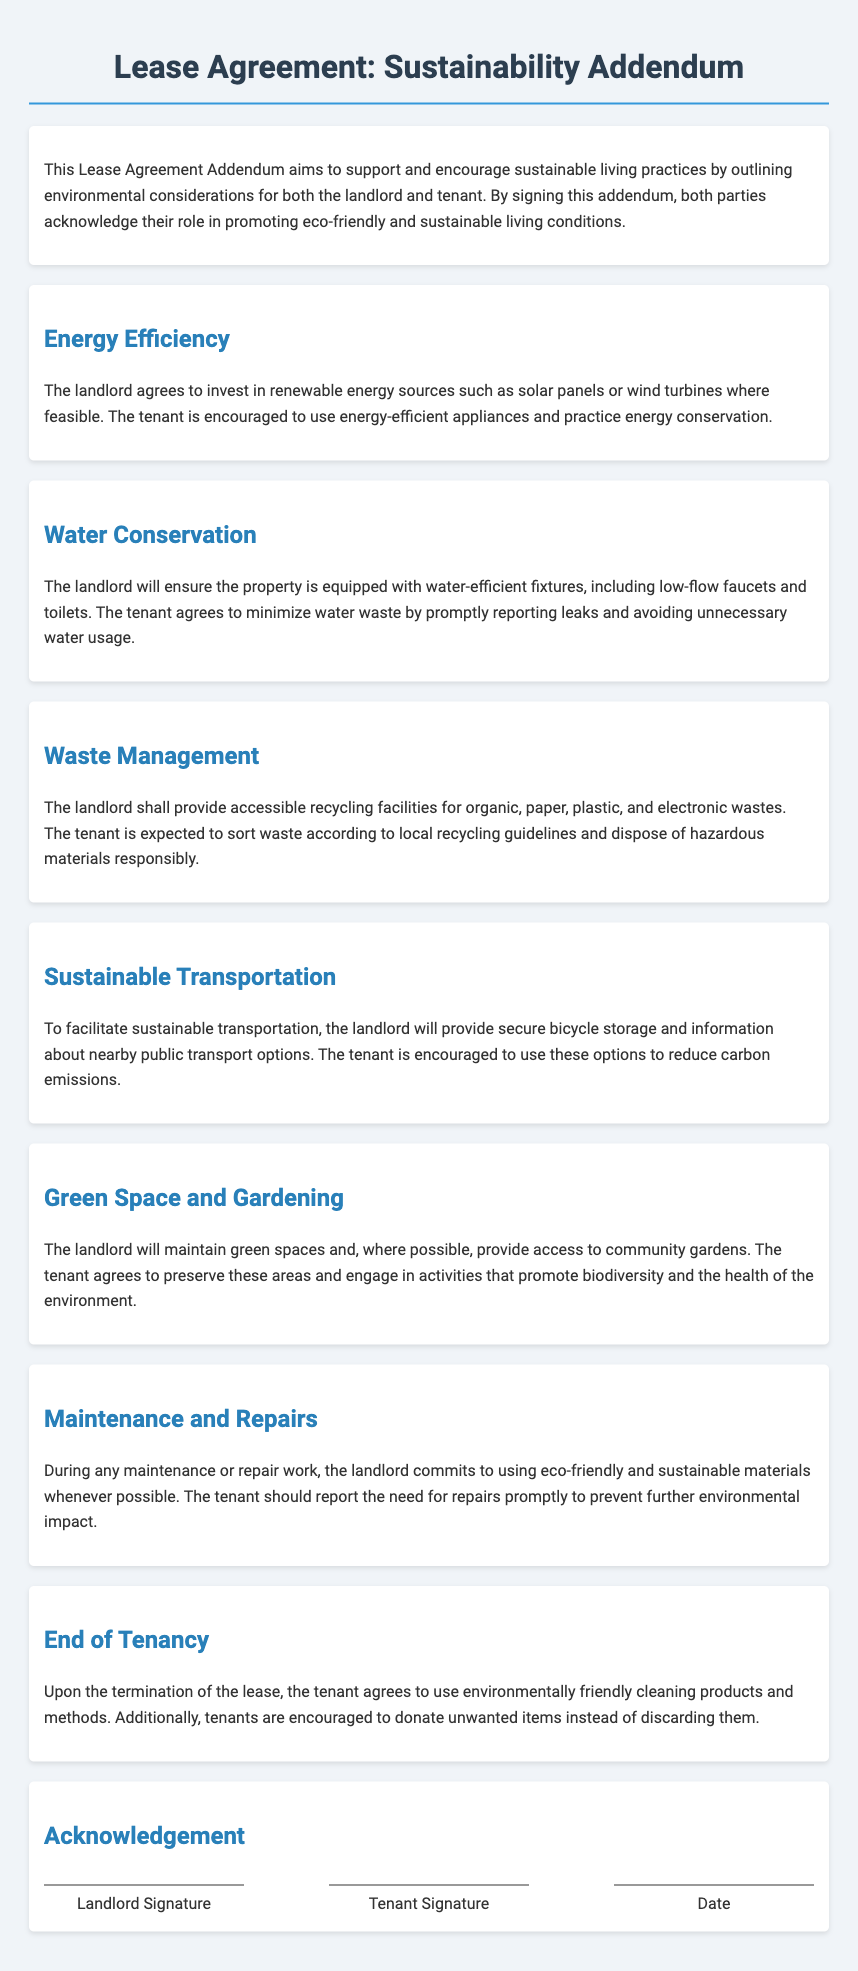What is the purpose of this Lease Agreement Addendum? The purpose is to support and encourage sustainable living practices by outlining environmental considerations for both the landlord and tenant.
Answer: To support and encourage sustainable living practices What energy sources is the landlord encouraged to invest in? The document states that the landlord agrees to invest in renewable energy sources where feasible.
Answer: Renewable energy sources What type of fixtures will the landlord ensure are installed in the property? The landlord will ensure the property is equipped with water-efficient fixtures.
Answer: Water-efficient fixtures What should the tenant do if they notice a leak? The tenant agrees to minimize water waste by promptly reporting leaks.
Answer: Promptly reporting leaks What is the tenant encouraged to use to reduce carbon emissions? The tenant is encouraged to use secure bicycle storage and information about nearby public transport options.
Answer: Public transport options What should be done with unwanted items at the end of the tenancy? The document encourages tenants to donate unwanted items instead of discarding them.
Answer: Donate unwanted items What type of materials should be used during maintenance or repair work? The landlord commits to using eco-friendly and sustainable materials whenever possible during maintenance or repair work.
Answer: Eco-friendly and sustainable materials 